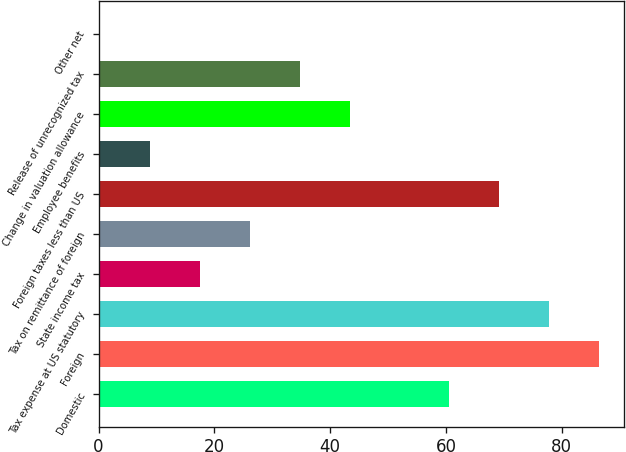Convert chart. <chart><loc_0><loc_0><loc_500><loc_500><bar_chart><fcel>Domestic<fcel>Foreign<fcel>Tax expense at US statutory<fcel>State income tax<fcel>Tax on remittance of foreign<fcel>Foreign taxes less than US<fcel>Employee benefits<fcel>Change in valuation allowance<fcel>Release of unrecognized tax<fcel>Other net<nl><fcel>60.57<fcel>86.4<fcel>77.79<fcel>17.52<fcel>26.13<fcel>69.18<fcel>8.91<fcel>43.35<fcel>34.74<fcel>0.3<nl></chart> 